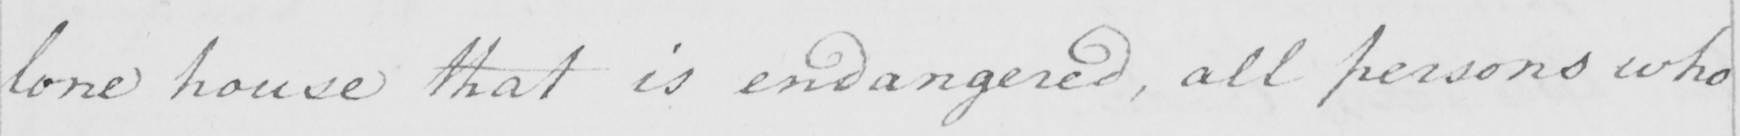Can you read and transcribe this handwriting? lone house that is endangered , all persons who 